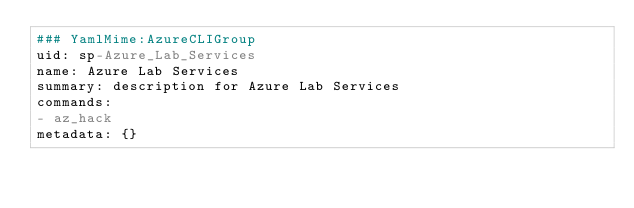Convert code to text. <code><loc_0><loc_0><loc_500><loc_500><_YAML_>### YamlMime:AzureCLIGroup
uid: sp-Azure_Lab_Services
name: Azure Lab Services
summary: description for Azure Lab Services
commands:
- az_hack
metadata: {}
</code> 